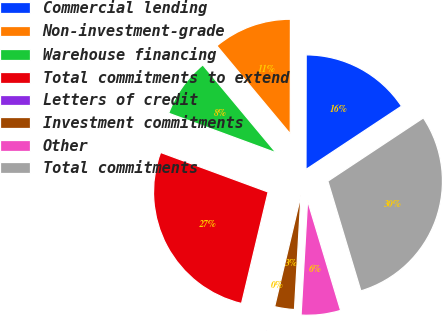<chart> <loc_0><loc_0><loc_500><loc_500><pie_chart><fcel>Commercial lending<fcel>Non-investment-grade<fcel>Warehouse financing<fcel>Total commitments to extend<fcel>Letters of credit<fcel>Investment commitments<fcel>Other<fcel>Total commitments<nl><fcel>15.66%<fcel>11.09%<fcel>8.32%<fcel>26.89%<fcel>0.03%<fcel>2.79%<fcel>5.56%<fcel>29.66%<nl></chart> 